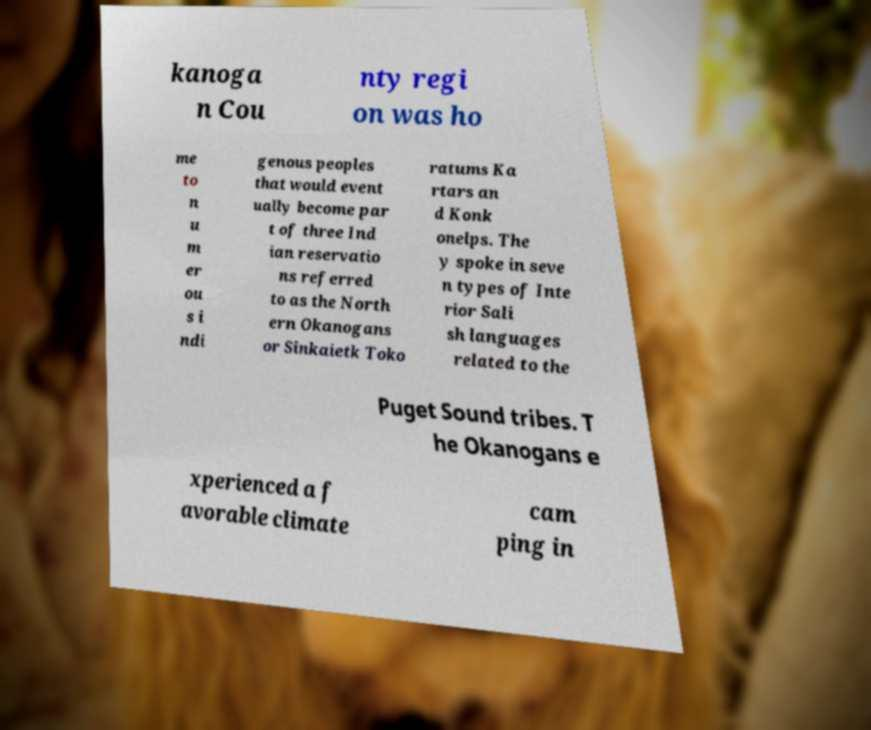Could you extract and type out the text from this image? kanoga n Cou nty regi on was ho me to n u m er ou s i ndi genous peoples that would event ually become par t of three Ind ian reservatio ns referred to as the North ern Okanogans or Sinkaietk Toko ratums Ka rtars an d Konk onelps. The y spoke in seve n types of Inte rior Sali sh languages related to the Puget Sound tribes. T he Okanogans e xperienced a f avorable climate cam ping in 